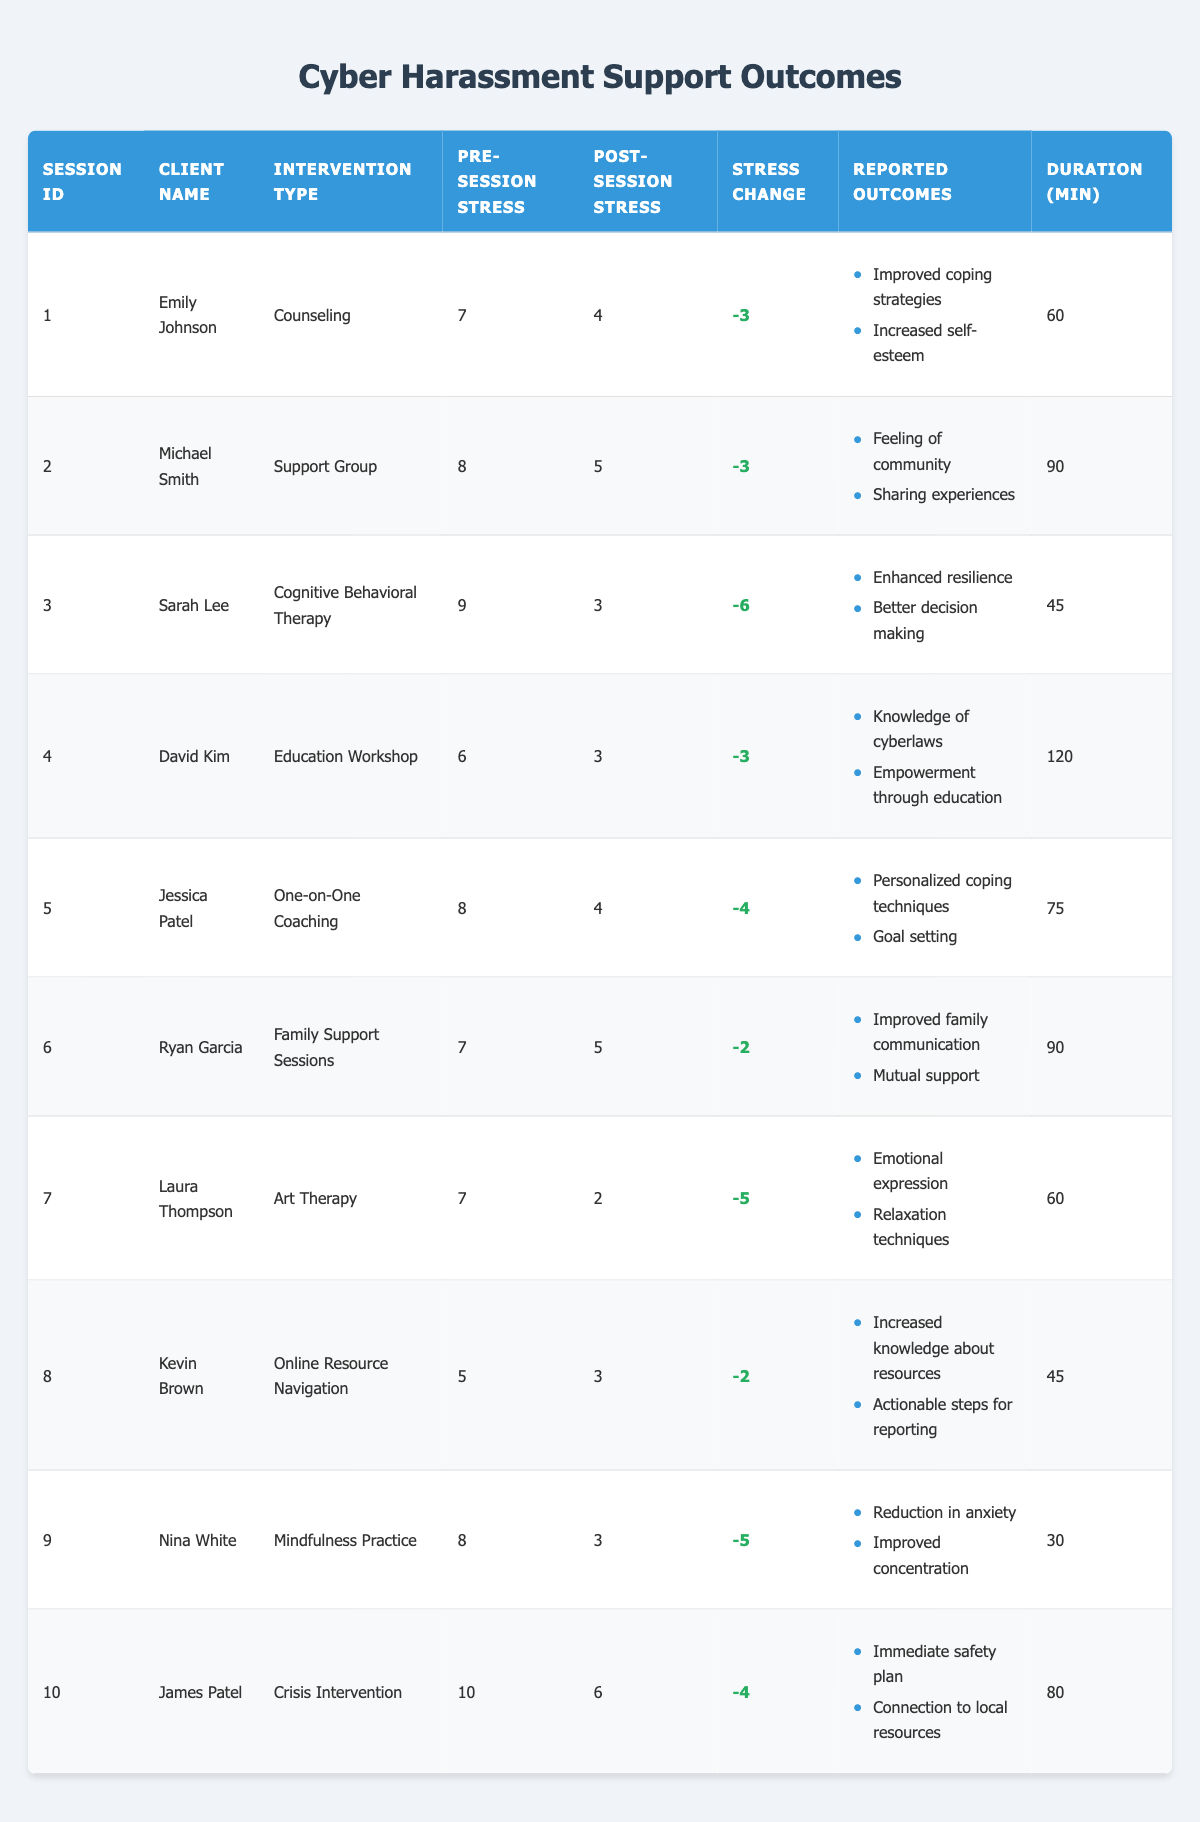What is the Intervention Type for Emily Johnson? The table shows that Emily Johnson's Intervention Type is listed under the "Intervention Type" column. From the row corresponding to her session, the value is "Counseling."
Answer: Counseling What was the pre-session stress level for Jessica Patel? In the row for Jessica Patel, the "Pre-Session Stress" column shows the value of 8.
Answer: 8 How much did the stress level decrease for Laura Thompson? For Laura Thompson, the "Stress Change" column indicates a value of -5, meaning her stress level decreased by 5 points.
Answer: 5 Which intervention type had the longest session duration? Reviewing the "Duration" column, the maximum value is in the row for David Kim, which shows 120 minutes for "Education Workshop."
Answer: Education Workshop What were the reported outcomes for Ryan Garcia’s session? In the row for Ryan Garcia, under the "Reported Outcomes" column, it lists "Improved family communication" and "Mutual support."
Answer: Improved family communication, Mutual support What was the average post-session stress level across all sessions? To find the average, sum the post-session stress levels (4 + 5 + 3 + 3 + 4 + 5 + 2 + 3 + 3 + 6 = 43) and divide by the number of clients (10). The average is 43/10 = 4.3.
Answer: 4.3 Did any clients report improvement in self-esteem? By looking in the reported outcomes for Emily Johnson, she mentioned "Increased self-esteem," indicating that at least one client did report this.
Answer: Yes Which client's stress level decreased the most after their session? The "Stress Change" values are reviewed; Sarah Lee has the largest decrease of 6 points (from 9 to 3).
Answer: Sarah Lee What is the post-session stress level for clients who received Cognitive Behavioral Therapy? Looking at the row for Sarah Lee, who underwent Cognitive Behavioral Therapy, the "Post-Session Stress" is recorded as 3.
Answer: 3 What intervention type did Kevin Brown receive, and how long was the session? Kevin Brown's intervention type is "Online Resource Navigation" and the "Duration" is 45 minutes.
Answer: Online Resource Navigation, 45 minutes 